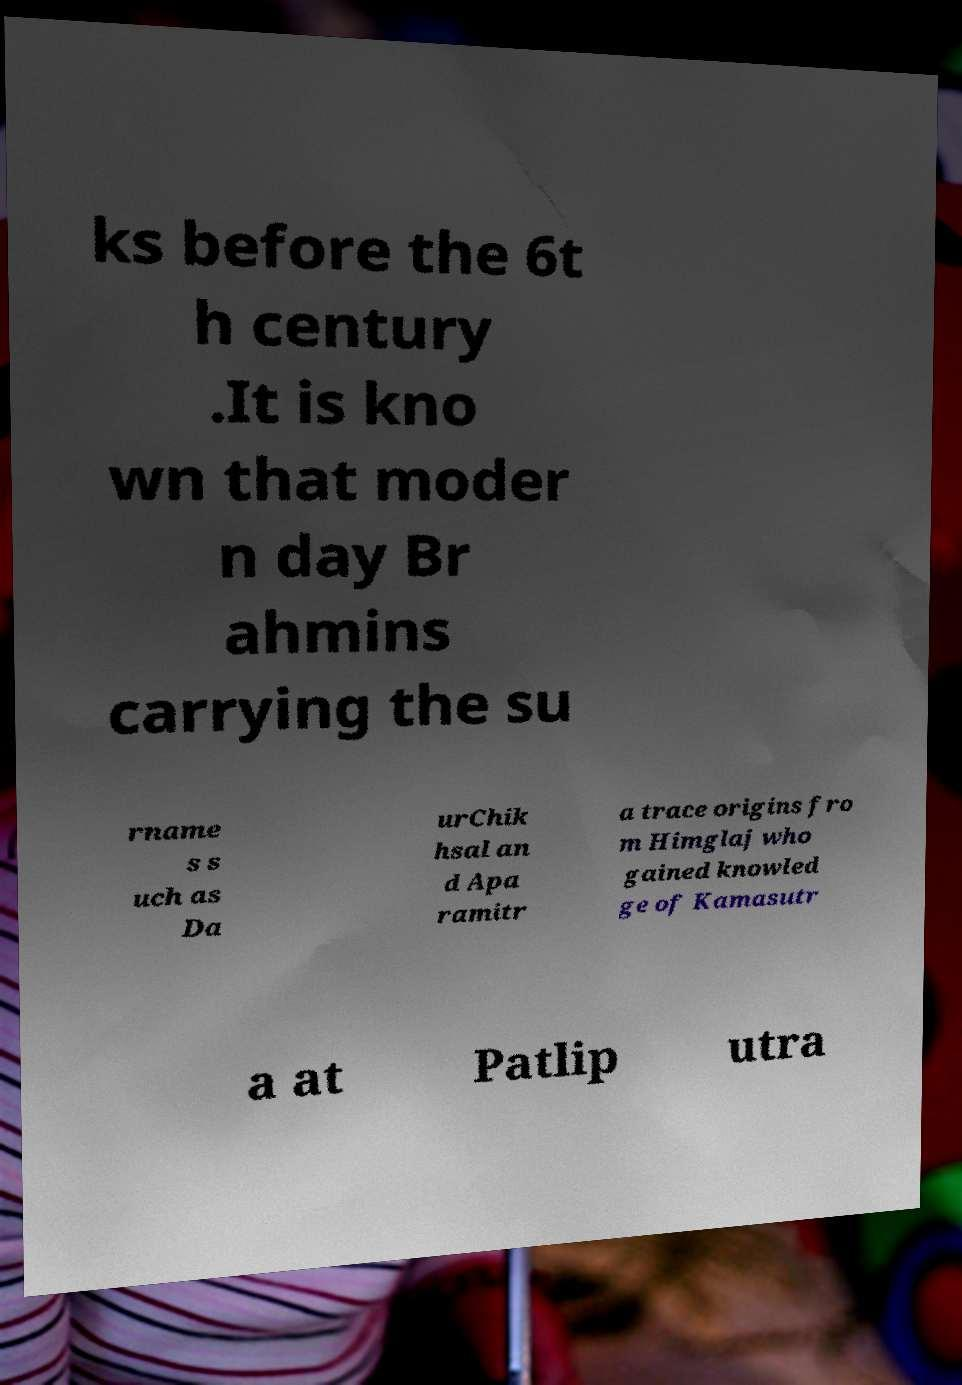What messages or text are displayed in this image? I need them in a readable, typed format. ks before the 6t h century .It is kno wn that moder n day Br ahmins carrying the su rname s s uch as Da urChik hsal an d Apa ramitr a trace origins fro m Himglaj who gained knowled ge of Kamasutr a at Patlip utra 